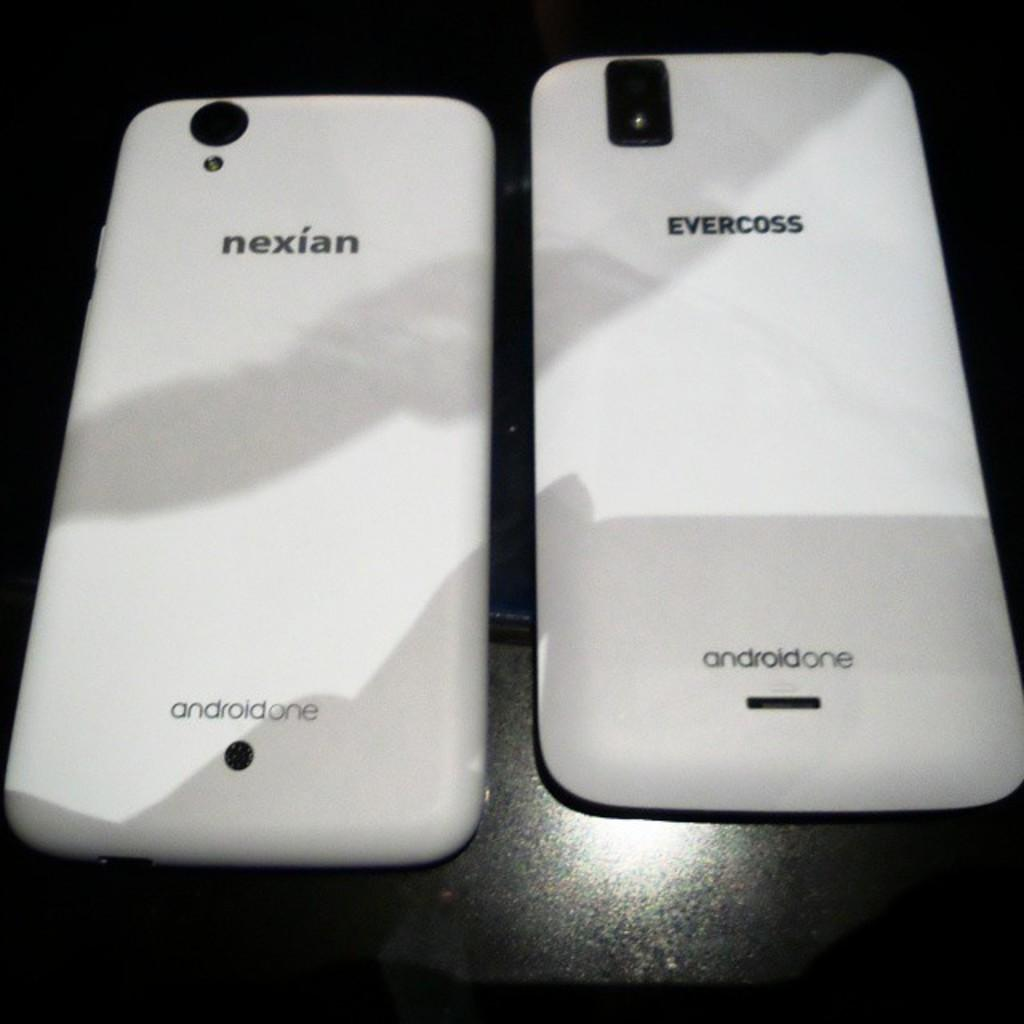<image>
Give a short and clear explanation of the subsequent image. Two cell phones are next to each other and they are both Android. 